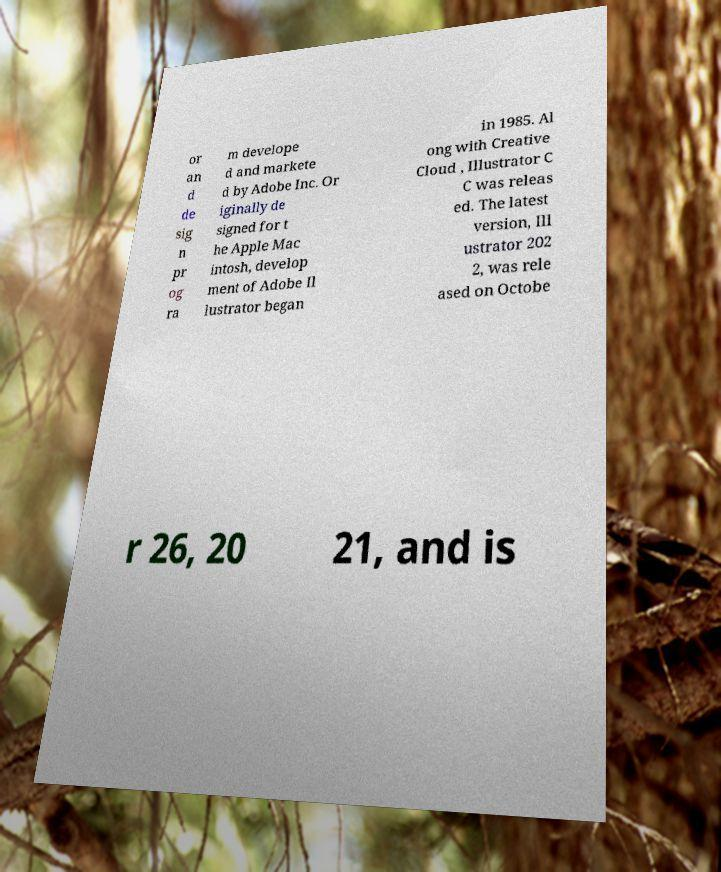Can you accurately transcribe the text from the provided image for me? or an d de sig n pr og ra m develope d and markete d by Adobe Inc. Or iginally de signed for t he Apple Mac intosh, develop ment of Adobe Il lustrator began in 1985. Al ong with Creative Cloud , Illustrator C C was releas ed. The latest version, Ill ustrator 202 2, was rele ased on Octobe r 26, 20 21, and is 